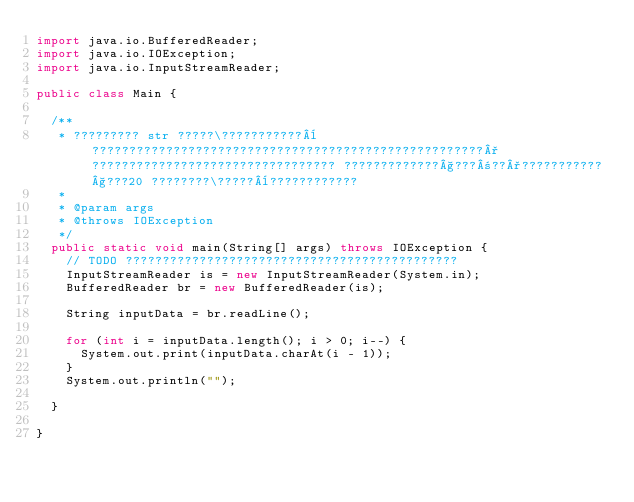Convert code to text. <code><loc_0><loc_0><loc_500><loc_500><_Java_>import java.io.BufferedReader;
import java.io.IOException;
import java.io.InputStreamReader;

public class Main {

	/**
	 * ????????? str ?????\???????????¨?????????????????????????????????????????????????????°????????????????????????????????? ?????????????§???±??°???????????§???20 ????????\?????¨????????????
	 * 
	 * @param args
	 * @throws IOException
	 */
	public static void main(String[] args) throws IOException {
		// TODO ?????????????????????????????????????????????
		InputStreamReader is = new InputStreamReader(System.in);
		BufferedReader br = new BufferedReader(is);

		String inputData = br.readLine();

		for (int i = inputData.length(); i > 0; i--) {
			System.out.print(inputData.charAt(i - 1));
		}
		System.out.println("");

	}

}</code> 